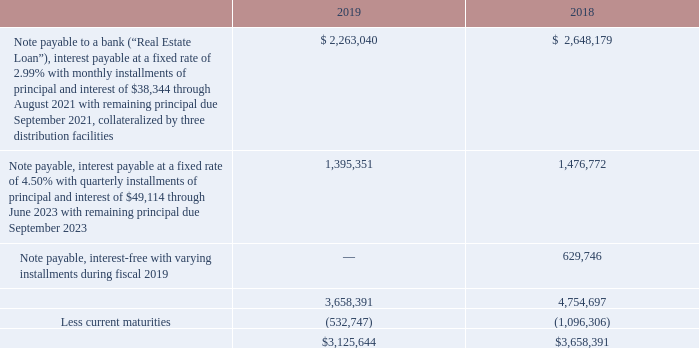LONG-TERM DEBT
In addition to the Facility, the Company also had the following long-term obligations at fiscal 2019 and fiscal 2018.
What are the respective values of the company's net long term debt in 2018 and 2019? $3,658,391, $3,125,644. What are the respective values of the company's current maturities in 2018 and 2019? 1,096,306, 532,747. What are the respective values of the company's interest-free note payable in 2018 and 2019? 629,746, 0. What is the percentage change in the company's net long-term debt between 2018 and 2019?
Answer scale should be: percent. (3,125,644 - 3,658,391)/3,658,391 
Answer: -14.56. What is the percentage change in the company's interest-free note payable between 2018 and 2019?
Answer scale should be: percent. (0 - 629,746)/629,746 
Answer: -100. What is the difference in the company's current maturities between 2018 and 2019? -532,747 - (1,096,306) 
Answer: 563559. 